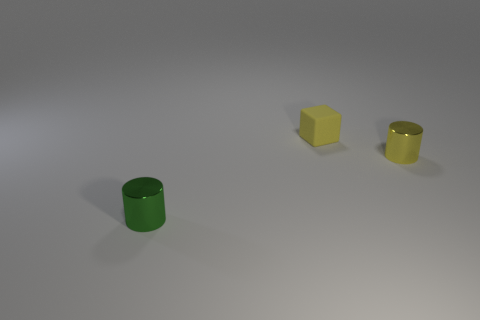Add 2 balls. How many objects exist? 5 Subtract all cylinders. How many objects are left? 1 Subtract 1 yellow cylinders. How many objects are left? 2 Subtract all tiny cylinders. Subtract all rubber things. How many objects are left? 0 Add 2 yellow cubes. How many yellow cubes are left? 3 Add 1 cylinders. How many cylinders exist? 3 